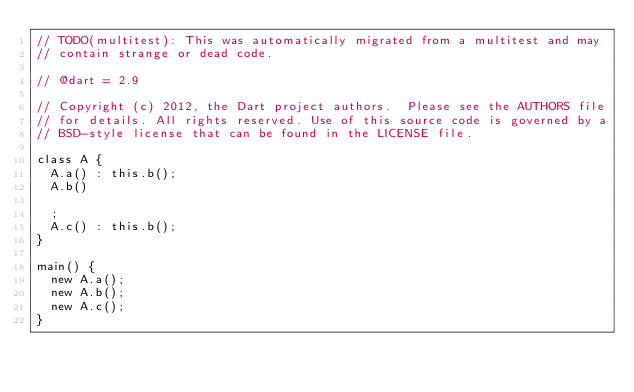Convert code to text. <code><loc_0><loc_0><loc_500><loc_500><_Dart_>// TODO(multitest): This was automatically migrated from a multitest and may
// contain strange or dead code.

// @dart = 2.9

// Copyright (c) 2012, the Dart project authors.  Please see the AUTHORS file
// for details. All rights reserved. Use of this source code is governed by a
// BSD-style license that can be found in the LICENSE file.

class A {
  A.a() : this.b();
  A.b()

  ;
  A.c() : this.b();
}

main() {
  new A.a();
  new A.b();
  new A.c();
}
</code> 